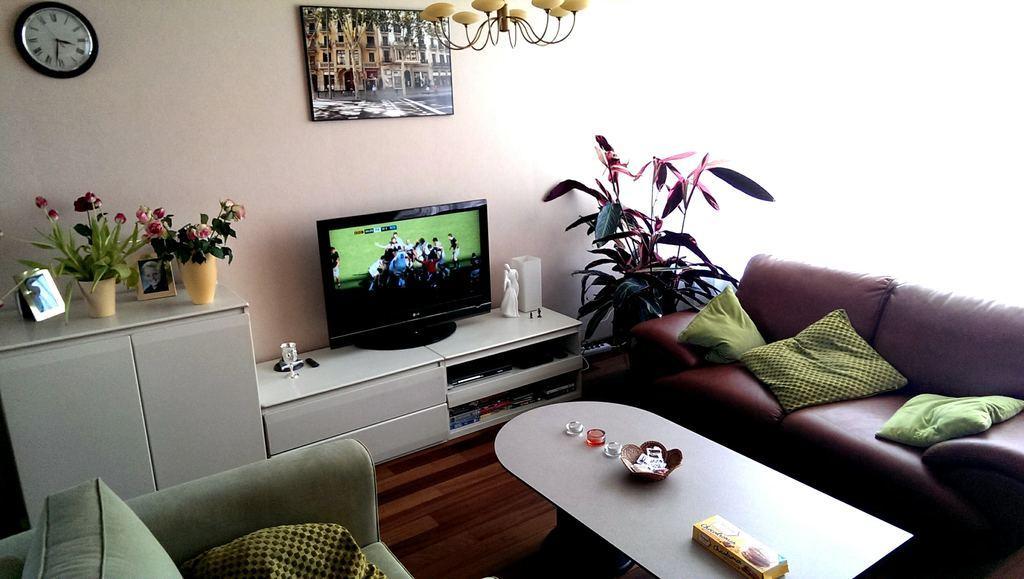How would you summarize this image in a sentence or two? This is a room. Inside the room there is a sofa. On the sofa there are pillows. On the table there is a box, basket and some other items. And there is a wall. On the wall there is a picture and a clock. There is a chandelier on the ceiling. There is a cupboard. On the cupboard there are two flower vases and flowers, photo frames, television, statue and some other items. In the corner there is a pot with a plant. 